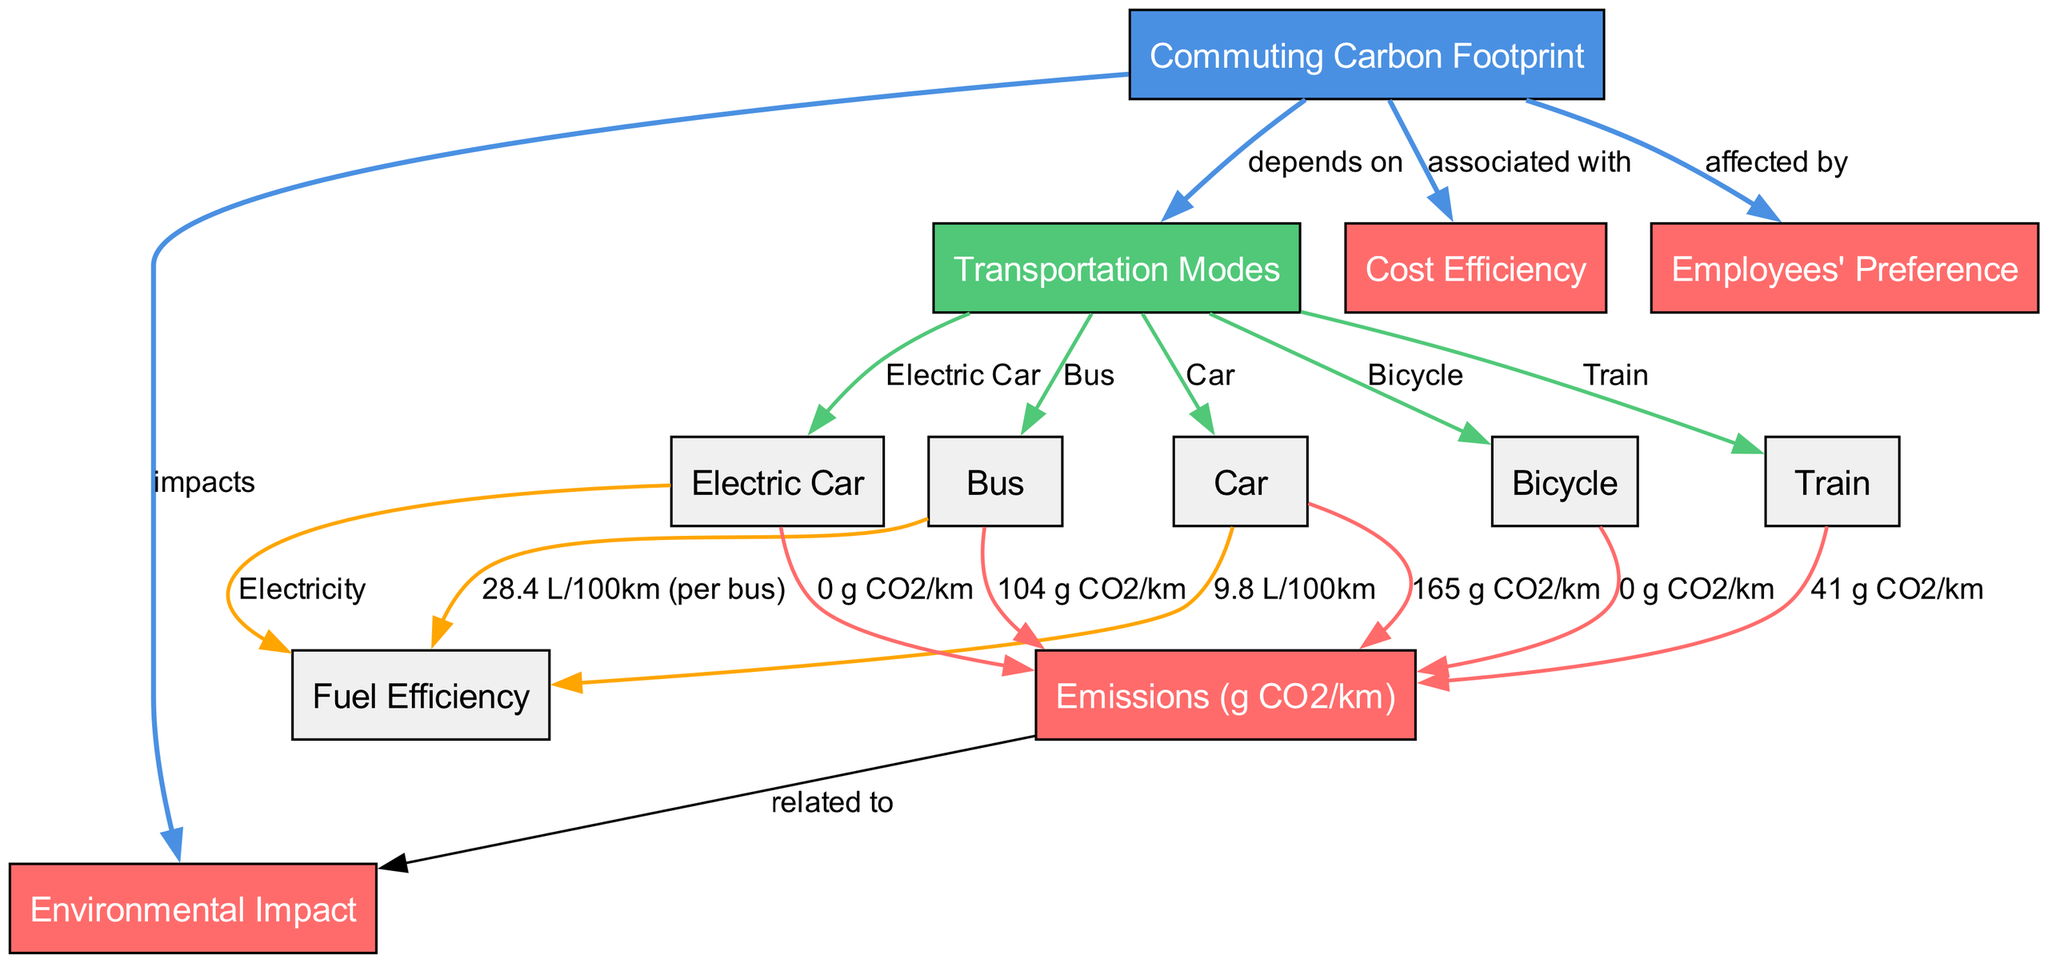What are the transportation modes represented in the diagram? The nodes connected to "Transportation Modes" (node 2) include "Car" (node 3), "Bus" (node 4), "Bicycle" (node 5), "Train" (node 6), and "Electric Car" (node 7). Each of these nodes represents a mode of transportation available to commuting employees.
Answer: Car, Bus, Bicycle, Train, Electric Car What is the carbon emission of the Bus? The "Bus" node (node 4) is directly connected to the emission value which is "104 g CO2/km" (node 9). This relationship indicates that the carbon emissions for a bus are quantified as per kilometer traveled.
Answer: 104 g CO2/km Which means of transportation is associated with zero emissions? The nodes "Bicycle" (node 5) and "Electric Car" (node 7) both connect to "0 g CO2/km" as their emissions, meaning these modes do not contribute to carbon emissions during commutes.
Answer: Bicycle, Electric Car What does the "Commuting Carbon Footprint" impact? The "Commuting Carbon Footprint" (node 1) has an edge leading to "Environmental Impact" (node 8) that shows a direct relationship, signifying that the carbon footprint directly impacts environmental conditions.
Answer: Environmental Impact What is the relationship between "Fuel Efficiency" and "Transportation Modes"? "Fuel Efficiency" (node 12) directly connects to the "Car" (node 3), "Bus" (node 4), and "Electric Car" (node 7), indicating that each of these modes has a distinct fuel efficiency rating displayed in the diagram. This suggests a performance metric associated with these transport options in relation to their efficiency in fuel usage.
Answer: Associated Which transportation mode shows the highest emissions? Among the transportation modes, "Car" (node 3) has the highest emissions value of "165 g CO2/km" (node 9), making it the mode with the greatest carbon footprint.
Answer: Car How many nodes are there related to costs? The "Cost Efficiency" (node 10) is noted as being "associated with" the "Commuting Carbon Footprint" (node 1). Since there is only one node related to cost (node 10) directly in the diagram, the result is one.
Answer: 1 In the context of employee preferences, how many modes are affected? The "Commuting Carbon Footprint" (node 1) is linked to the "Employees' Preference" (node 11), but it does not specify how many modes are explicitly preferred. However, since multiple transportation modes exist in the diagram, we can consider that all five (Car, Bus, Bicycle, Train, Electric Car) may influence preferences but are not counted separately under node 11. Therefore, despite many modes, the answer focuses on the direct impact by stating all transportation modes may relate to preferences overall.
Answer: All modes 